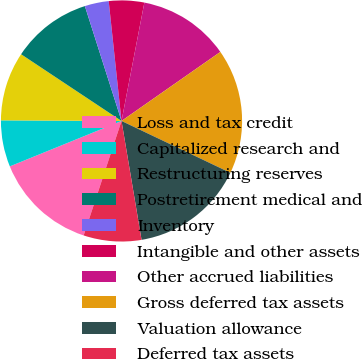Convert chart to OTSL. <chart><loc_0><loc_0><loc_500><loc_500><pie_chart><fcel>Loss and tax credit<fcel>Capitalized research and<fcel>Restructuring reserves<fcel>Postretirement medical and<fcel>Inventory<fcel>Intangible and other assets<fcel>Other accrued liabilities<fcel>Gross deferred tax assets<fcel>Valuation allowance<fcel>Deferred tax assets<nl><fcel>13.77%<fcel>6.23%<fcel>9.25%<fcel>10.75%<fcel>3.22%<fcel>4.73%<fcel>12.26%<fcel>16.78%<fcel>15.27%<fcel>7.74%<nl></chart> 